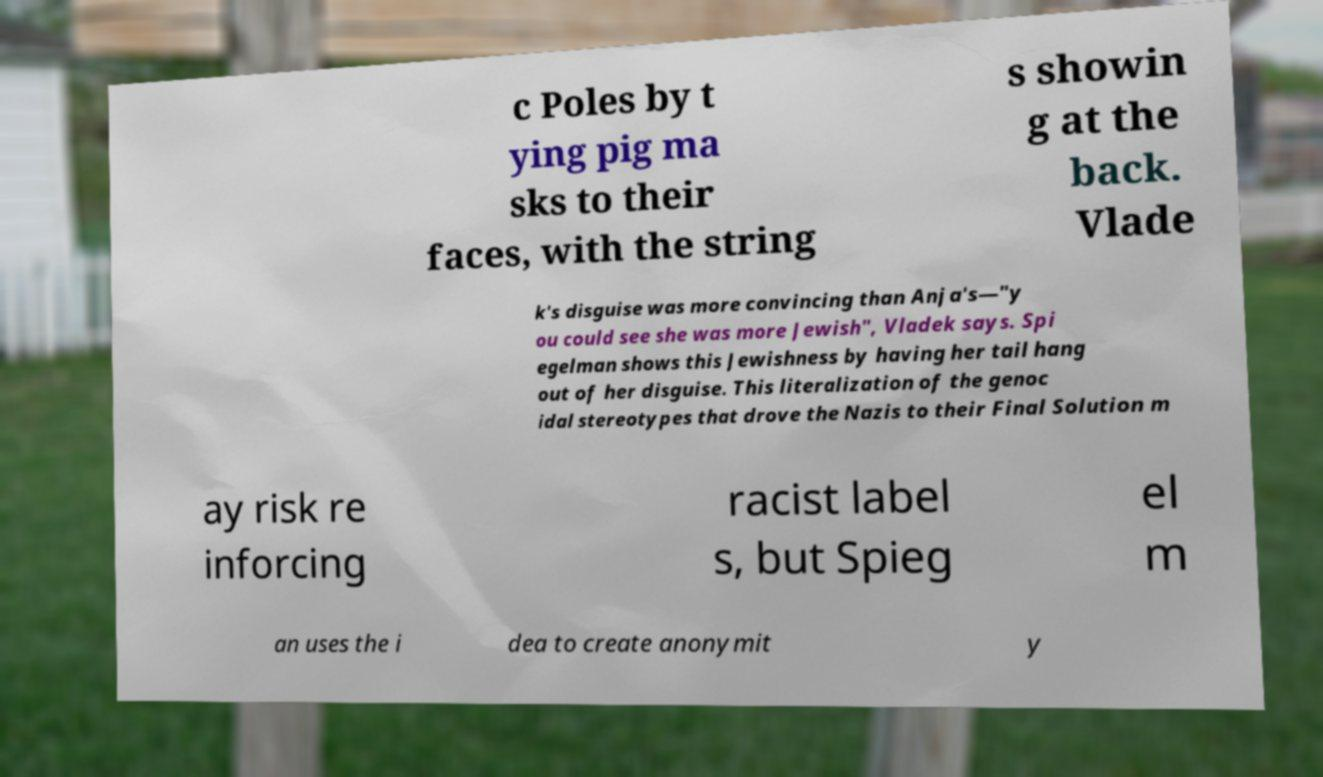Could you assist in decoding the text presented in this image and type it out clearly? c Poles by t ying pig ma sks to their faces, with the string s showin g at the back. Vlade k's disguise was more convincing than Anja's—"y ou could see she was more Jewish", Vladek says. Spi egelman shows this Jewishness by having her tail hang out of her disguise. This literalization of the genoc idal stereotypes that drove the Nazis to their Final Solution m ay risk re inforcing racist label s, but Spieg el m an uses the i dea to create anonymit y 